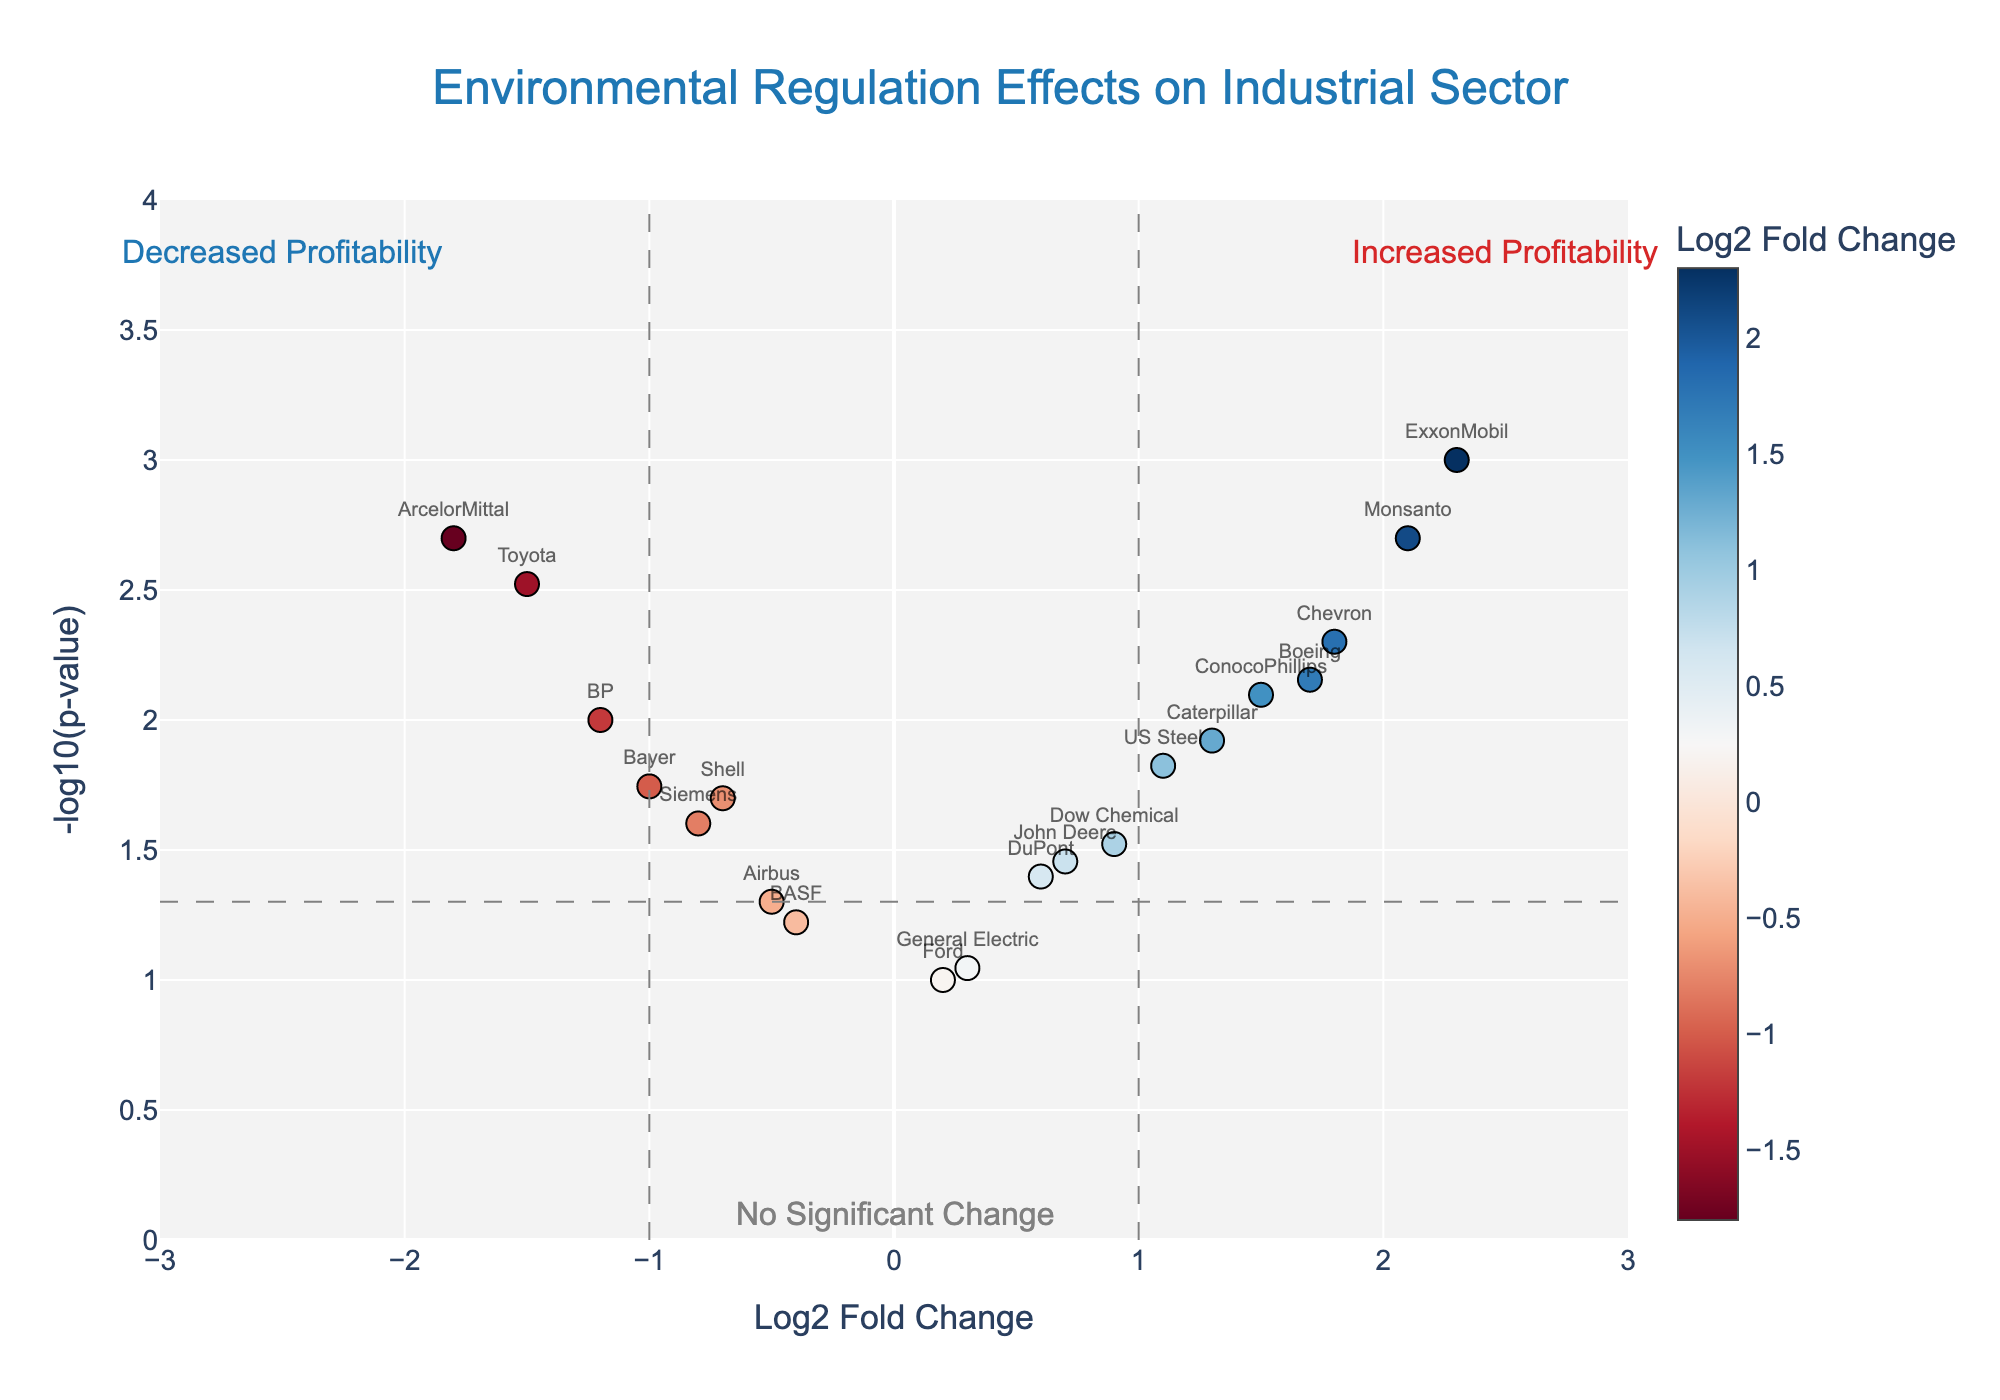What is the title of the plot? The title is located at the top of the figure and is displayed in a large font.
Answer: Environmental Regulation Effects on Industrial Sector Which industry shows the highest log2 fold change increase? The highest log2 fold change increase is represented by the data point furthest to the right on the x-axis.
Answer: ExxonMobil Which industries have a significant decrease in profitability as shown by being below the threshold line for -log10(p-value)? Industries below the threshold line for -log10(p-value) < 1.3 and with negative log2 fold changes are considered to have a significant decrease in profitability.
Answer: Shell, BP, ArcelorMittal, Siemens, Toyota, Bayer How many industries show an increased profitability (positive log2 fold change) with a p-value lower than 0.05? We look for data points with positive log2 fold changes and -log10(p-value) greater than 1.3 (representing p-value < 0.05).
Answer: Six industries Which industry is closest to having no significant change in profitability due to environmental regulation? The industry closest to the origin (0 on the x-axis and low y-axis value) represents no significant change.
Answer: Ford What is the log2 fold change for Boeing, and is it significant? By identifying the data point labeled "Boeing" on the plot, we can read its log2 fold change and check if its -log10(p-value) is above the threshold line.
Answer: 1.7, significant Compare the effects on profitability between ExxonMobil and ArcelorMittal. Which experienced a greater impact in absolute terms? We compare the absolute values of log2 fold changes for ExxonMobil and ArcelorMittal, taking the one with the greater magnitude.
Answer: ExxonMobil Which industries have a log2 fold change between -1 and 1 and are not considered significant (p-value greater than 0.05)? We identify points within the range -1 < log2 fold change < 1 and below the threshold line (-log10(p-value) < 1.3).
Answer: Dow Chemical, DuPont, BASF, General Electric, John Deere, Airbus Evaluate the impact on profitability for ExxonMobil and Chevron. Who has a larger log2 fold change and are both significant? Checking log2 fold changes and -log10(p-values) for the two companies to see both the magnitude and significance.
Answer: ExxonMobil has a larger log2 fold change, and both are significant How many industries have a -log10(p-value) higher than 2? Counting the number of data points above the y-axis value of 2 (representing more significant results).
Answer: Six industries 